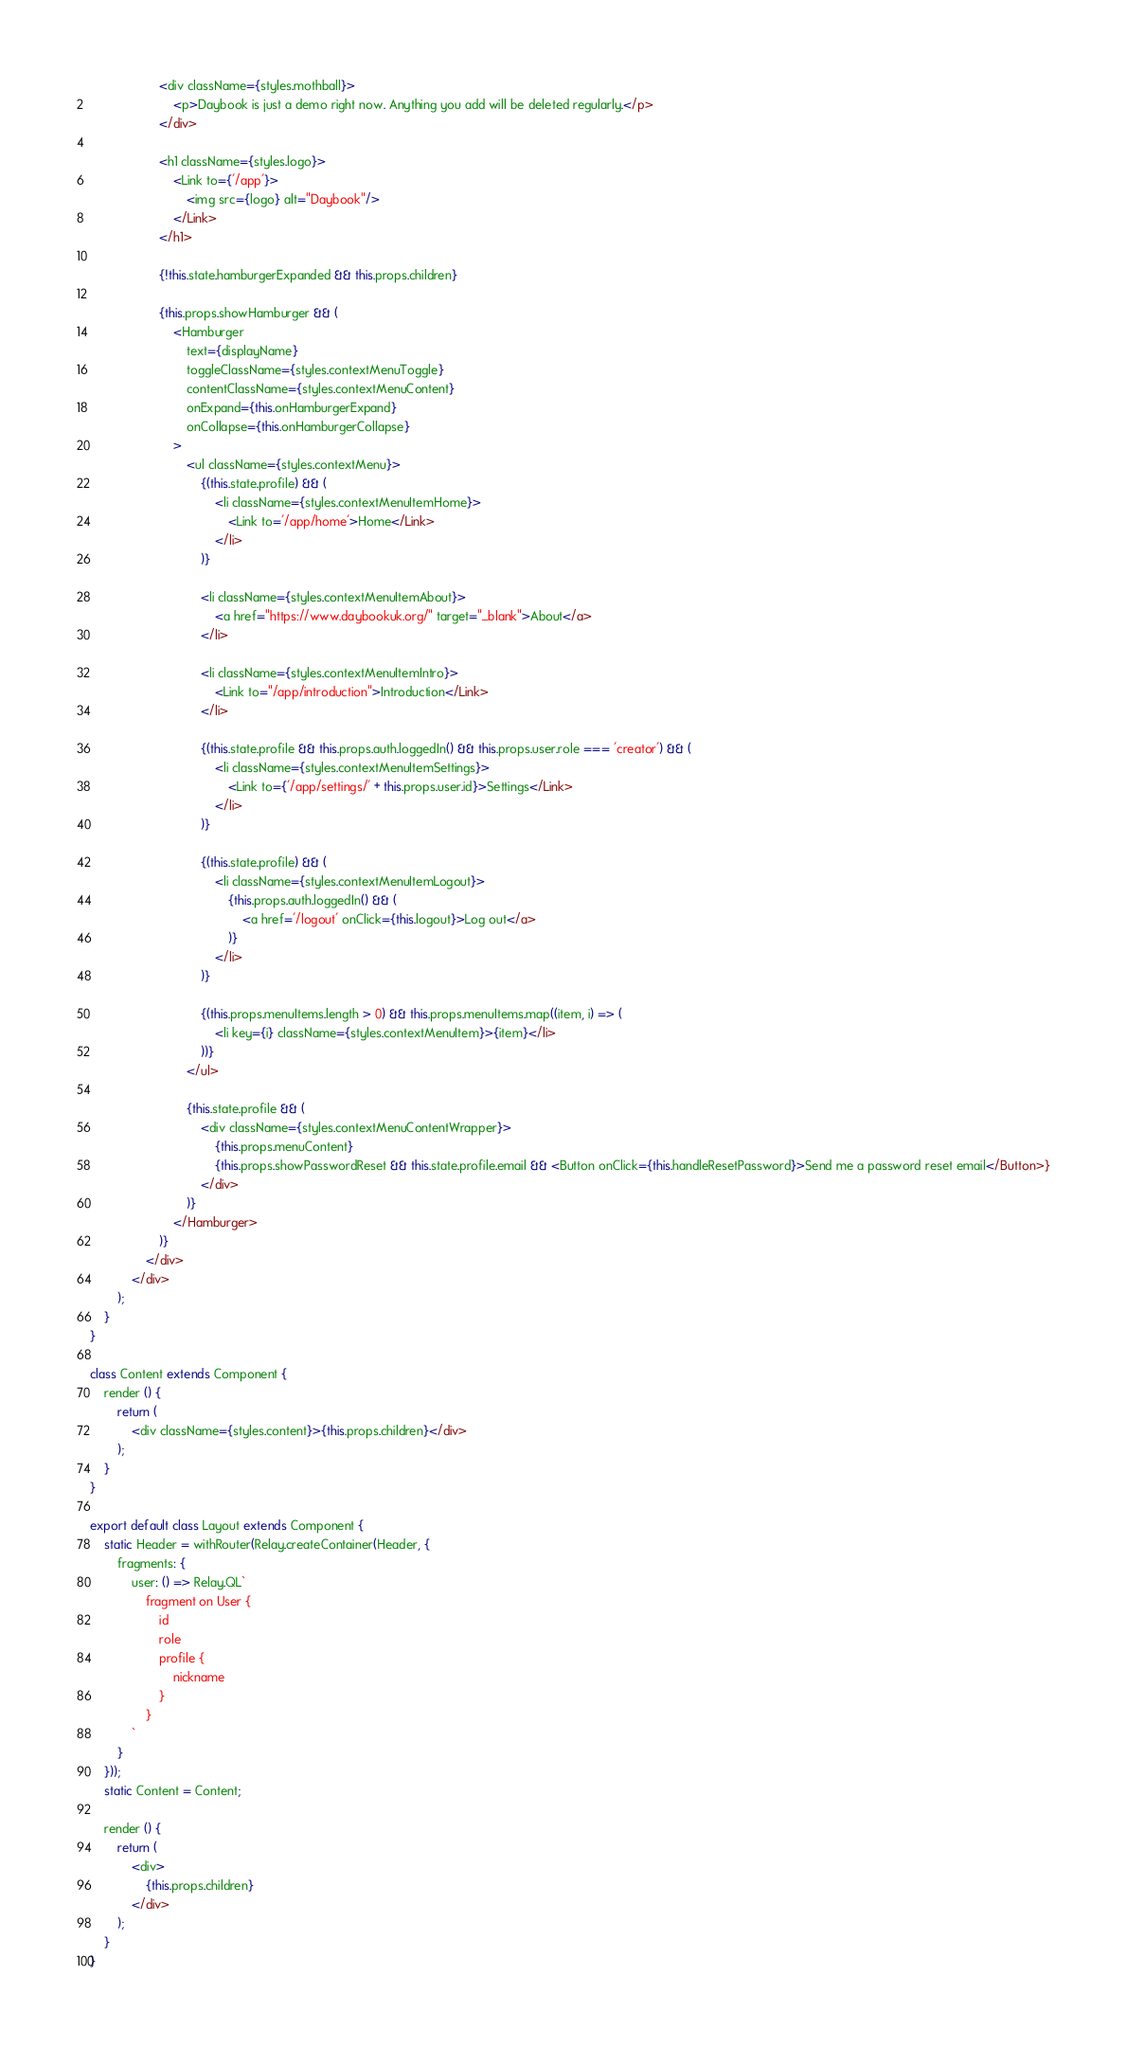Convert code to text. <code><loc_0><loc_0><loc_500><loc_500><_JavaScript_>                    <div className={styles.mothball}>
                        <p>Daybook is just a demo right now. Anything you add will be deleted regularly.</p>
                    </div>

                    <h1 className={styles.logo}>
                        <Link to={'/app'}>
                            <img src={logo} alt="Daybook"/>
                        </Link>
                    </h1>

                    {!this.state.hamburgerExpanded && this.props.children}

                    {this.props.showHamburger && (
                        <Hamburger
                            text={displayName}
                            toggleClassName={styles.contextMenuToggle}
                            contentClassName={styles.contextMenuContent}
                            onExpand={this.onHamburgerExpand}
                            onCollapse={this.onHamburgerCollapse}
                        >
                            <ul className={styles.contextMenu}>
                                {(this.state.profile) && (
                                    <li className={styles.contextMenuItemHome}>
                                        <Link to='/app/home'>Home</Link>
                                    </li>
                                )}

                                <li className={styles.contextMenuItemAbout}>
                                    <a href="https://www.daybookuk.org/" target="_blank">About</a>
                                </li>

                                <li className={styles.contextMenuItemIntro}>
                                    <Link to="/app/introduction">Introduction</Link>
                                </li>

                                {(this.state.profile && this.props.auth.loggedIn() && this.props.user.role === 'creator') && (
                                    <li className={styles.contextMenuItemSettings}>
                                        <Link to={'/app/settings/' + this.props.user.id}>Settings</Link>
                                    </li>
                                )}

                                {(this.state.profile) && (
                                    <li className={styles.contextMenuItemLogout}>
                                        {this.props.auth.loggedIn() && (
                                            <a href='/logout' onClick={this.logout}>Log out</a>
                                        )}
                                    </li>
                                )}

                                {(this.props.menuItems.length > 0) && this.props.menuItems.map((item, i) => (
                                    <li key={i} className={styles.contextMenuItem}>{item}</li>
                                ))}
                            </ul>

                            {this.state.profile && (
                                <div className={styles.contextMenuContentWrapper}>
                                    {this.props.menuContent}
                                    {this.props.showPasswordReset && this.state.profile.email && <Button onClick={this.handleResetPassword}>Send me a password reset email</Button>}
                                </div>
                            )}
                        </Hamburger>
                    )}
                </div>
            </div>
        );
    }
}

class Content extends Component {
    render () {
        return (
            <div className={styles.content}>{this.props.children}</div>
        );
    }
}

export default class Layout extends Component {
    static Header = withRouter(Relay.createContainer(Header, {
        fragments: {
            user: () => Relay.QL`
                fragment on User {
                    id
                    role
                    profile {
                        nickname
                    }
                }
            `
        }
    }));
    static Content = Content;

    render () {
        return (
            <div>
                {this.props.children}
            </div>
        );
    }
}
</code> 